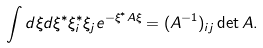Convert formula to latex. <formula><loc_0><loc_0><loc_500><loc_500>\int d \xi d \xi ^ { * } \xi ^ { * } _ { i } \xi _ { j } e ^ { - \xi ^ { * } A \xi } = ( A ^ { - 1 } ) _ { i j } \det A .</formula> 